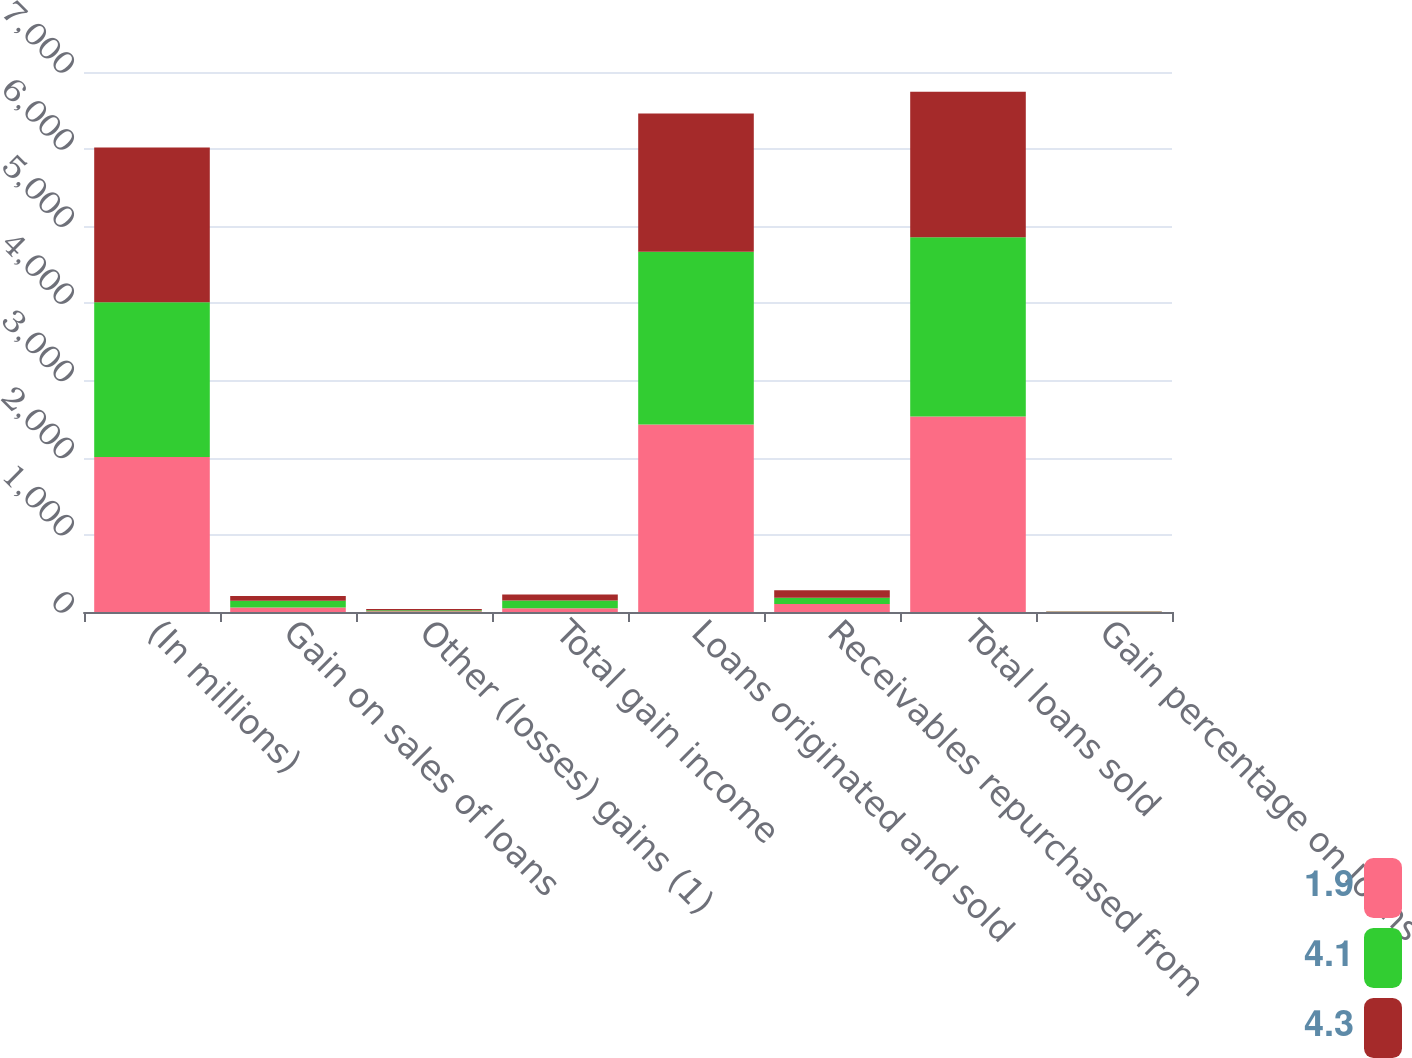Convert chart. <chart><loc_0><loc_0><loc_500><loc_500><stacked_bar_chart><ecel><fcel>(In millions)<fcel>Gain on sales of loans<fcel>Other (losses) gains (1)<fcel>Total gain income<fcel>Loans originated and sold<fcel>Receivables repurchased from<fcel>Total loans sold<fcel>Gain percentage on loans<nl><fcel>1.9<fcel>2008<fcel>58.1<fcel>9.6<fcel>48.5<fcel>2430.8<fcel>103.6<fcel>2534.4<fcel>2.4<nl><fcel>4.1<fcel>2007<fcel>86.7<fcel>13<fcel>99.7<fcel>2240.2<fcel>82.5<fcel>2322.7<fcel>3.9<nl><fcel>4.3<fcel>2006<fcel>61.9<fcel>15.2<fcel>77.1<fcel>1792.6<fcel>94.8<fcel>1887.5<fcel>3.5<nl></chart> 